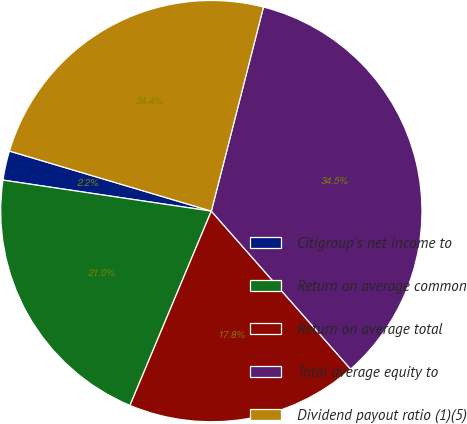Convert chart. <chart><loc_0><loc_0><loc_500><loc_500><pie_chart><fcel>Citigroup's net income to<fcel>Return on average common<fcel>Return on average total<fcel>Total average equity to<fcel>Dividend payout ratio (1)(5)<nl><fcel>2.25%<fcel>21.04%<fcel>17.81%<fcel>34.52%<fcel>24.38%<nl></chart> 